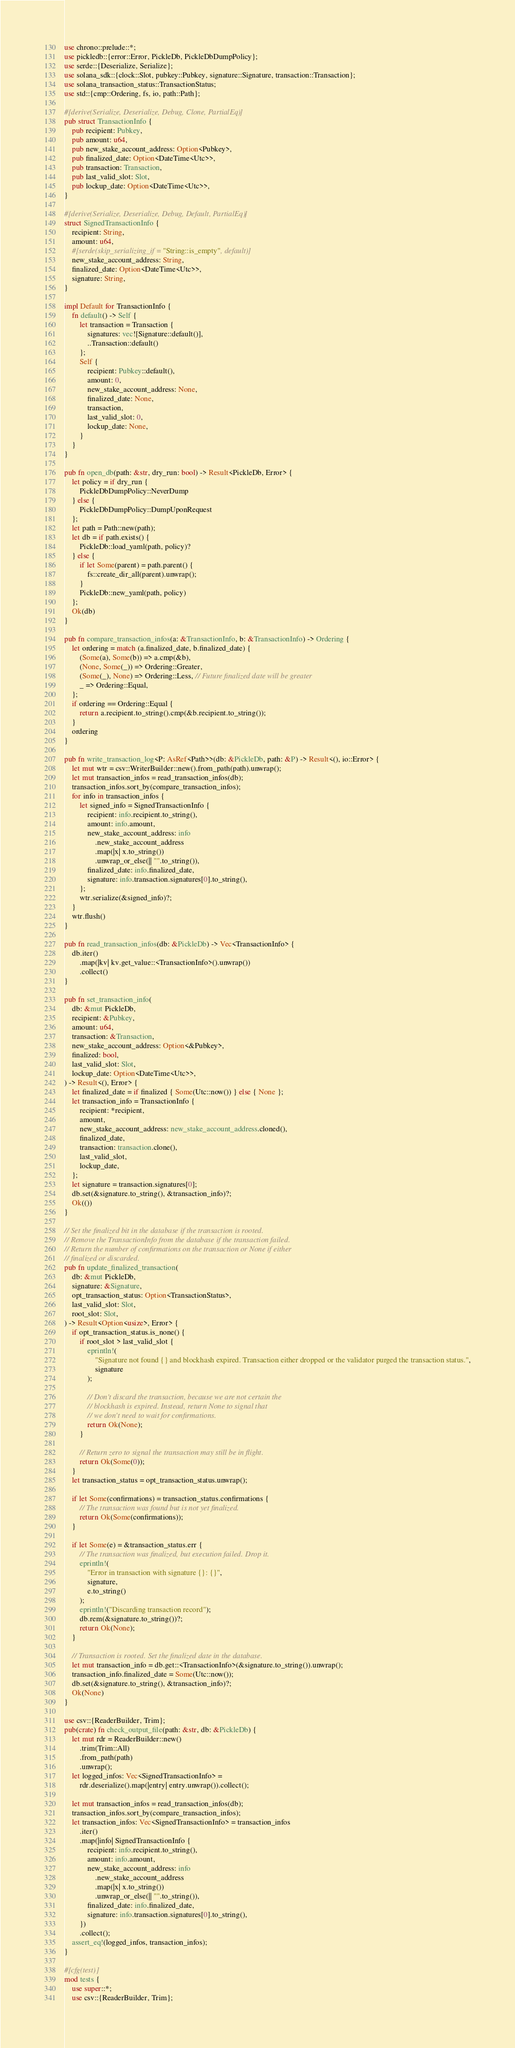Convert code to text. <code><loc_0><loc_0><loc_500><loc_500><_Rust_>use chrono::prelude::*;
use pickledb::{error::Error, PickleDb, PickleDbDumpPolicy};
use serde::{Deserialize, Serialize};
use solana_sdk::{clock::Slot, pubkey::Pubkey, signature::Signature, transaction::Transaction};
use solana_transaction_status::TransactionStatus;
use std::{cmp::Ordering, fs, io, path::Path};

#[derive(Serialize, Deserialize, Debug, Clone, PartialEq)]
pub struct TransactionInfo {
    pub recipient: Pubkey,
    pub amount: u64,
    pub new_stake_account_address: Option<Pubkey>,
    pub finalized_date: Option<DateTime<Utc>>,
    pub transaction: Transaction,
    pub last_valid_slot: Slot,
    pub lockup_date: Option<DateTime<Utc>>,
}

#[derive(Serialize, Deserialize, Debug, Default, PartialEq)]
struct SignedTransactionInfo {
    recipient: String,
    amount: u64,
    #[serde(skip_serializing_if = "String::is_empty", default)]
    new_stake_account_address: String,
    finalized_date: Option<DateTime<Utc>>,
    signature: String,
}

impl Default for TransactionInfo {
    fn default() -> Self {
        let transaction = Transaction {
            signatures: vec![Signature::default()],
            ..Transaction::default()
        };
        Self {
            recipient: Pubkey::default(),
            amount: 0,
            new_stake_account_address: None,
            finalized_date: None,
            transaction,
            last_valid_slot: 0,
            lockup_date: None,
        }
    }
}

pub fn open_db(path: &str, dry_run: bool) -> Result<PickleDb, Error> {
    let policy = if dry_run {
        PickleDbDumpPolicy::NeverDump
    } else {
        PickleDbDumpPolicy::DumpUponRequest
    };
    let path = Path::new(path);
    let db = if path.exists() {
        PickleDb::load_yaml(path, policy)?
    } else {
        if let Some(parent) = path.parent() {
            fs::create_dir_all(parent).unwrap();
        }
        PickleDb::new_yaml(path, policy)
    };
    Ok(db)
}

pub fn compare_transaction_infos(a: &TransactionInfo, b: &TransactionInfo) -> Ordering {
    let ordering = match (a.finalized_date, b.finalized_date) {
        (Some(a), Some(b)) => a.cmp(&b),
        (None, Some(_)) => Ordering::Greater,
        (Some(_), None) => Ordering::Less, // Future finalized date will be greater
        _ => Ordering::Equal,
    };
    if ordering == Ordering::Equal {
        return a.recipient.to_string().cmp(&b.recipient.to_string());
    }
    ordering
}

pub fn write_transaction_log<P: AsRef<Path>>(db: &PickleDb, path: &P) -> Result<(), io::Error> {
    let mut wtr = csv::WriterBuilder::new().from_path(path).unwrap();
    let mut transaction_infos = read_transaction_infos(db);
    transaction_infos.sort_by(compare_transaction_infos);
    for info in transaction_infos {
        let signed_info = SignedTransactionInfo {
            recipient: info.recipient.to_string(),
            amount: info.amount,
            new_stake_account_address: info
                .new_stake_account_address
                .map(|x| x.to_string())
                .unwrap_or_else(|| "".to_string()),
            finalized_date: info.finalized_date,
            signature: info.transaction.signatures[0].to_string(),
        };
        wtr.serialize(&signed_info)?;
    }
    wtr.flush()
}

pub fn read_transaction_infos(db: &PickleDb) -> Vec<TransactionInfo> {
    db.iter()
        .map(|kv| kv.get_value::<TransactionInfo>().unwrap())
        .collect()
}

pub fn set_transaction_info(
    db: &mut PickleDb,
    recipient: &Pubkey,
    amount: u64,
    transaction: &Transaction,
    new_stake_account_address: Option<&Pubkey>,
    finalized: bool,
    last_valid_slot: Slot,
    lockup_date: Option<DateTime<Utc>>,
) -> Result<(), Error> {
    let finalized_date = if finalized { Some(Utc::now()) } else { None };
    let transaction_info = TransactionInfo {
        recipient: *recipient,
        amount,
        new_stake_account_address: new_stake_account_address.cloned(),
        finalized_date,
        transaction: transaction.clone(),
        last_valid_slot,
        lockup_date,
    };
    let signature = transaction.signatures[0];
    db.set(&signature.to_string(), &transaction_info)?;
    Ok(())
}

// Set the finalized bit in the database if the transaction is rooted.
// Remove the TransactionInfo from the database if the transaction failed.
// Return the number of confirmations on the transaction or None if either
// finalized or discarded.
pub fn update_finalized_transaction(
    db: &mut PickleDb,
    signature: &Signature,
    opt_transaction_status: Option<TransactionStatus>,
    last_valid_slot: Slot,
    root_slot: Slot,
) -> Result<Option<usize>, Error> {
    if opt_transaction_status.is_none() {
        if root_slot > last_valid_slot {
            eprintln!(
                "Signature not found {} and blockhash expired. Transaction either dropped or the validator purged the transaction status.",
                signature
            );

            // Don't discard the transaction, because we are not certain the
            // blockhash is expired. Instead, return None to signal that
            // we don't need to wait for confirmations.
            return Ok(None);
        }

        // Return zero to signal the transaction may still be in flight.
        return Ok(Some(0));
    }
    let transaction_status = opt_transaction_status.unwrap();

    if let Some(confirmations) = transaction_status.confirmations {
        // The transaction was found but is not yet finalized.
        return Ok(Some(confirmations));
    }

    if let Some(e) = &transaction_status.err {
        // The transaction was finalized, but execution failed. Drop it.
        eprintln!(
            "Error in transaction with signature {}: {}",
            signature,
            e.to_string()
        );
        eprintln!("Discarding transaction record");
        db.rem(&signature.to_string())?;
        return Ok(None);
    }

    // Transaction is rooted. Set the finalized date in the database.
    let mut transaction_info = db.get::<TransactionInfo>(&signature.to_string()).unwrap();
    transaction_info.finalized_date = Some(Utc::now());
    db.set(&signature.to_string(), &transaction_info)?;
    Ok(None)
}

use csv::{ReaderBuilder, Trim};
pub(crate) fn check_output_file(path: &str, db: &PickleDb) {
    let mut rdr = ReaderBuilder::new()
        .trim(Trim::All)
        .from_path(path)
        .unwrap();
    let logged_infos: Vec<SignedTransactionInfo> =
        rdr.deserialize().map(|entry| entry.unwrap()).collect();

    let mut transaction_infos = read_transaction_infos(db);
    transaction_infos.sort_by(compare_transaction_infos);
    let transaction_infos: Vec<SignedTransactionInfo> = transaction_infos
        .iter()
        .map(|info| SignedTransactionInfo {
            recipient: info.recipient.to_string(),
            amount: info.amount,
            new_stake_account_address: info
                .new_stake_account_address
                .map(|x| x.to_string())
                .unwrap_or_else(|| "".to_string()),
            finalized_date: info.finalized_date,
            signature: info.transaction.signatures[0].to_string(),
        })
        .collect();
    assert_eq!(logged_infos, transaction_infos);
}

#[cfg(test)]
mod tests {
    use super::*;
    use csv::{ReaderBuilder, Trim};</code> 